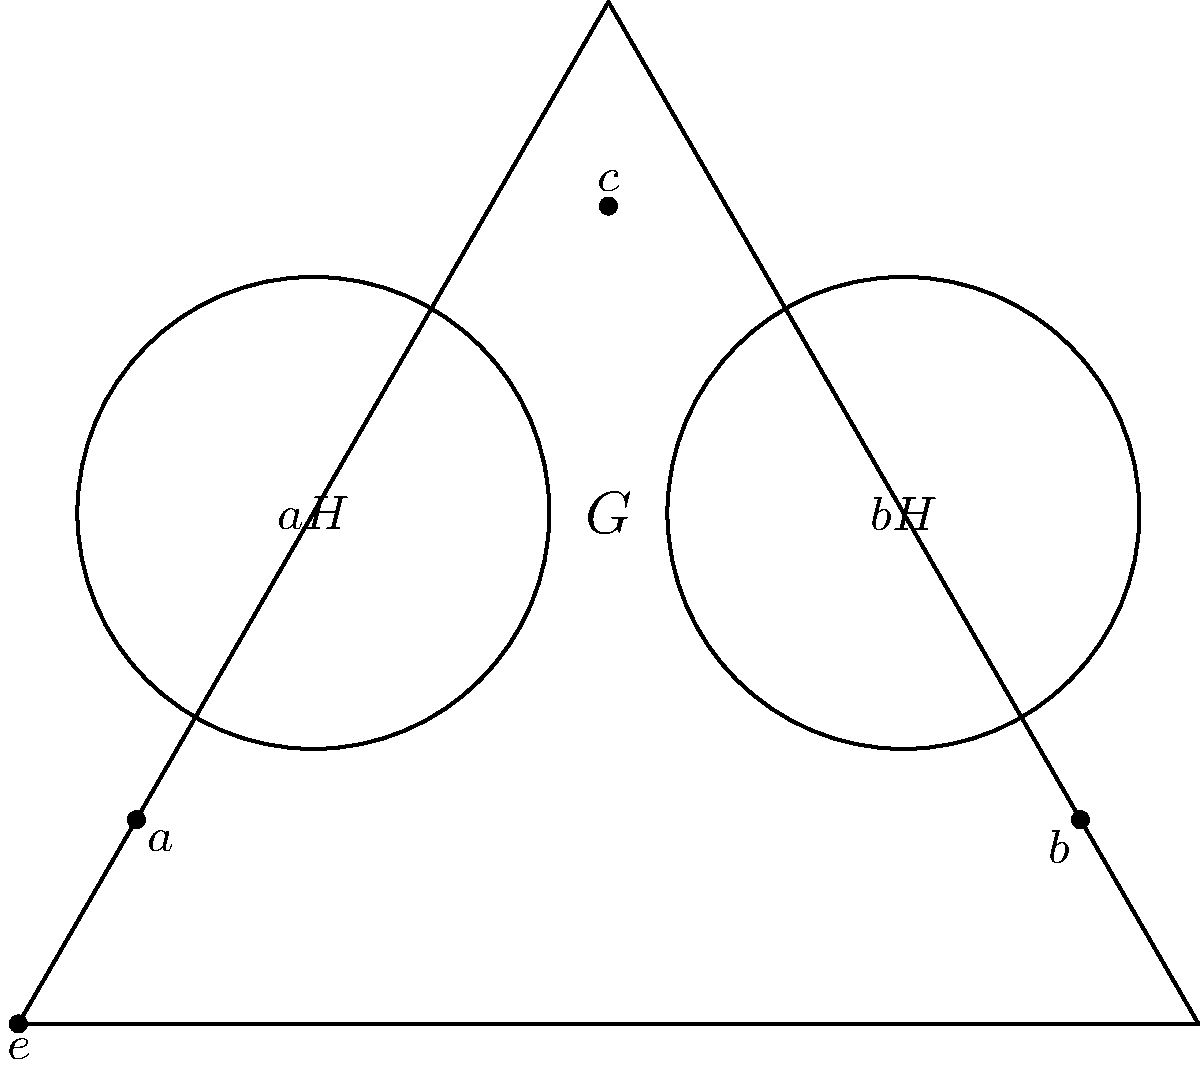In the Venn diagram representing a group $G$ with elements $\{e, a, b, c\}$, two cosets $aH$ and $bH$ of a subgroup $H$ are shown. If $e$ is the identity element and $H = \{e, c\}$, determine the order of the group $G$ and explain why $aH \neq bH$. Let's approach this step-by-step:

1) First, we need to understand what the diagram represents:
   - The triangle represents the entire group $G$.
   - The two circles represent cosets $aH$ and $bH$.
   - We're given that $H = \{e, c\}$.

2) To determine the order of $G$:
   - We can simply count the elements: $G = \{e, a, b, c\}$
   - Therefore, the order of $G$ is 4.

3) To explain why $aH \neq bH$:
   - Recall that for a subgroup $H$ and an element $g$ of $G$, $gH = \{gh : h \in H\}$
   - So, $aH = \{ae, ac\} = \{a, ac\}$
   - And $bH = \{be, bc\} = \{b, bc\}$

4) From the diagram, we can see that:
   - $aH$ contains $a$ and $c$
   - $bH$ contains $b$ and $c$

5) Since $a \neq b$, and they are in different cosets, $aH \neq bH$.

This illustrates an important property of cosets: they are either identical or disjoint. Here, they share one element ($c$) but are not identical, so they must be disjoint.
Answer: Order of $G$ is 4; $aH \neq bH$ because $a \in aH$ but $a \notin bH$. 